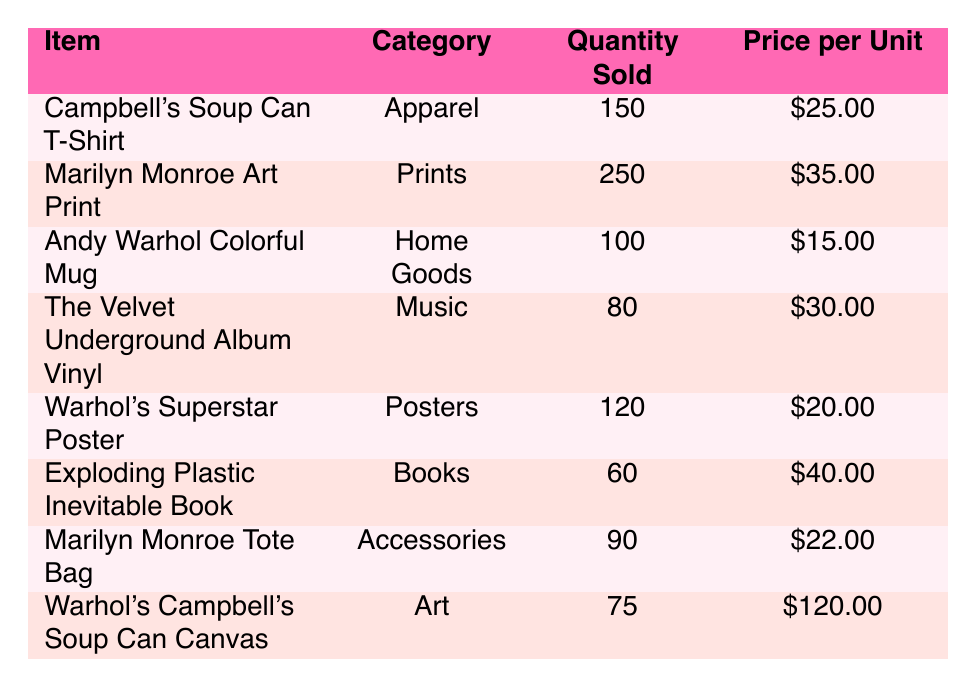What is the quantity sold of the Marilyn Monroe Art Print? The table lists the Marilyn Monroe Art Print with a quantity sold of 250.
Answer: 250 Which item in the Accessories category has the highest quantity sold? The table shows the Marilyn Monroe Tote Bag in the Accessories category with a quantity sold of 90, and it is the only item in the Accessories category, making it the highest.
Answer: Marilyn Monroe Tote Bag What is the total quantity sold for all items listed in the table? To find the total quantity sold, we add the quantity sold for all items: 150 + 250 + 100 + 80 + 120 + 60 + 90 + 75 = 925.
Answer: 925 Is the price per unit of Warhol's Campbell's Soup Can Canvas higher than the price per unit of the Exploding Plastic Inevitable Book? The price of Warhol's Campbell's Soup Can Canvas is 120, while the price of the Exploding Plastic Inevitable Book is 40. Since 120 is greater than 40, the answer is yes.
Answer: Yes What is the average price per unit for all items in the table? To find the average, we sum the price per unit: 25 + 35 + 15 + 30 + 20 + 40 + 22 + 120 = 337. Then, we divide by the number of items, which is 8. The average is 337 / 8 = 42.13.
Answer: 42.13 Which category has the least quantity sold and what is that quantity? By examining the quantity sold in each category, the quantity sold in the Books category is the lowest at 60.
Answer: Books, 60 How many more units of the Marilyn Monroe Art Print were sold compared to the Warhol's Campbell's Soup Can Canvas? Marilyn Monroe Art Print sold 250 units and the Warhol's Campbell's Soup Can Canvas sold 75 units. Calculating the difference, 250 - 75 = 175 units more.
Answer: 175 Are there more items in the Art category or the Home Goods category? There is only one item in each category, making it equal.
Answer: Equal 